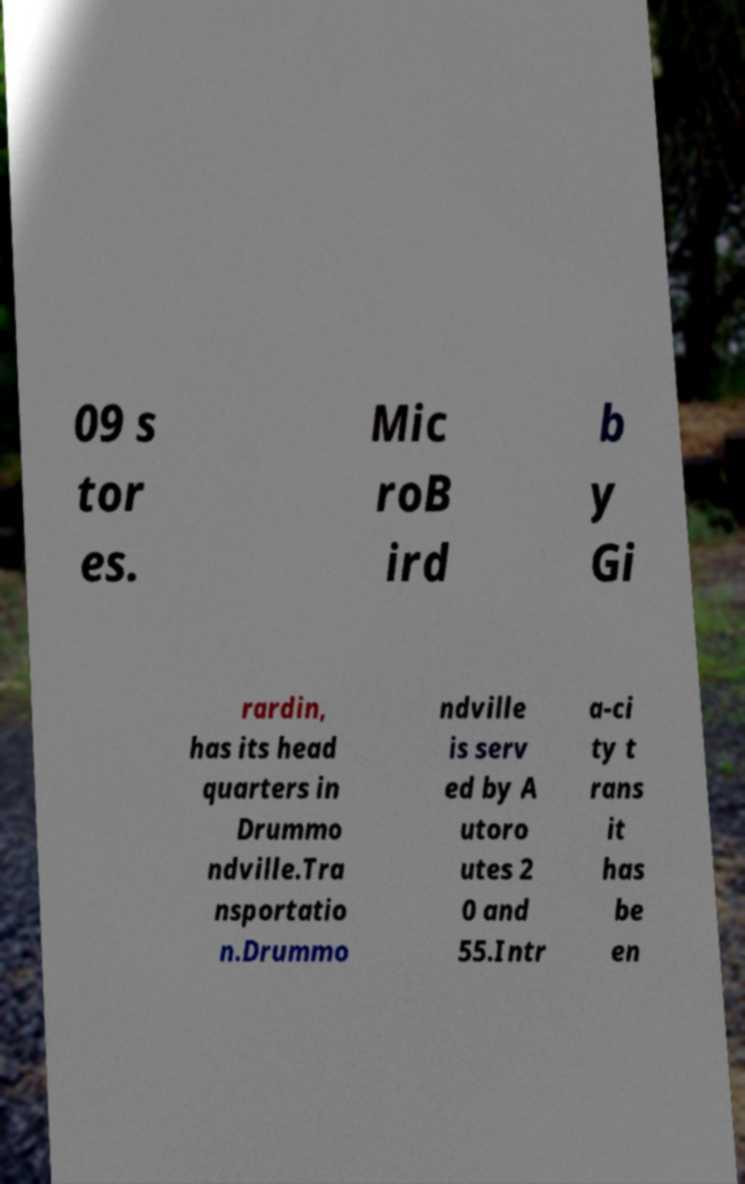Can you read and provide the text displayed in the image?This photo seems to have some interesting text. Can you extract and type it out for me? 09 s tor es. Mic roB ird b y Gi rardin, has its head quarters in Drummo ndville.Tra nsportatio n.Drummo ndville is serv ed by A utoro utes 2 0 and 55.Intr a-ci ty t rans it has be en 